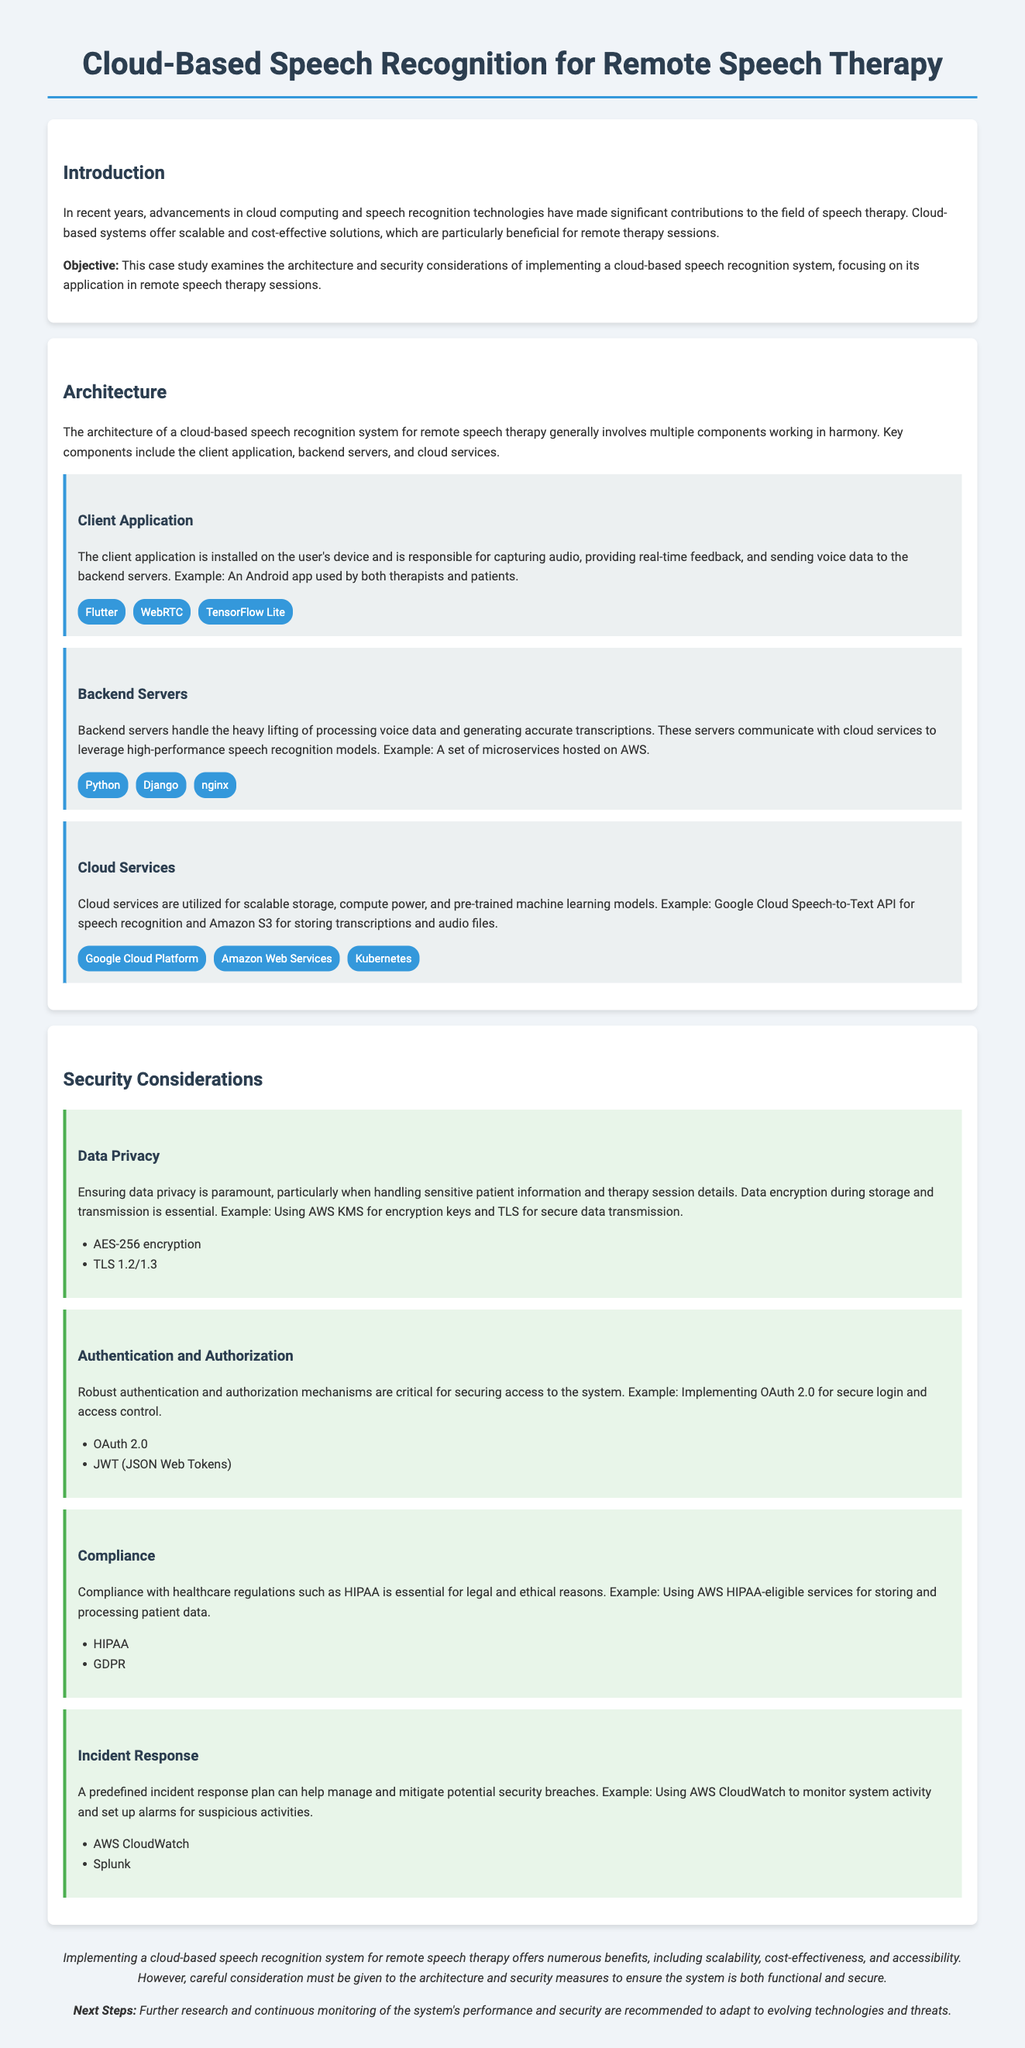what is the main objective of the case study? The objective is to examine the architecture and security considerations of implementing a cloud-based speech recognition system.
Answer: examine architecture and security considerations what type of application is responsible for capturing audio? The client application is responsible for capturing audio and providing real-time feedback.
Answer: client application which encryption standard is mentioned for data privacy? The document mentions AES-256 encryption as the encryption standard for data privacy.
Answer: AES-256 what technology is suggested for backend server handling? The technology suggested for backend server handling includes Python and Django.
Answer: Python and Django which cloud service is used for speech recognition in the architecture? The Google Cloud Speech-to-Text API is used for speech recognition.
Answer: Google Cloud Speech-to-Text API name one authentication method mentioned in the security considerations. OAuth 2.0 is mentioned as an authentication method.
Answer: OAuth 2.0 how many components are there in the architecture section? There are three components mentioned in the architecture section.
Answer: three what is crucial for managing potential security breaches? A predefined incident response plan is crucial for managing potential security breaches.
Answer: incident response plan which healthcare regulation is mentioned for compliance? HIPAA is the healthcare regulation mentioned for compliance.
Answer: HIPAA 